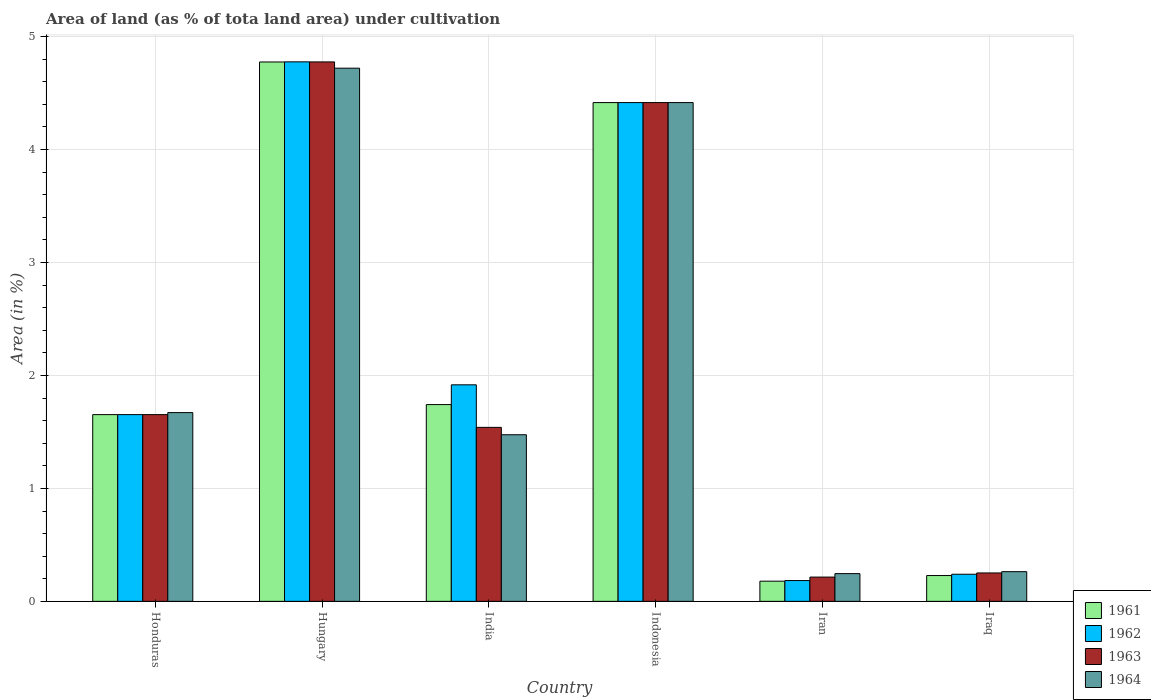How many groups of bars are there?
Provide a succinct answer. 6. Are the number of bars per tick equal to the number of legend labels?
Keep it short and to the point. Yes. How many bars are there on the 3rd tick from the left?
Your response must be concise. 4. How many bars are there on the 3rd tick from the right?
Offer a very short reply. 4. What is the label of the 2nd group of bars from the left?
Make the answer very short. Hungary. What is the percentage of land under cultivation in 1962 in Indonesia?
Your response must be concise. 4.42. Across all countries, what is the maximum percentage of land under cultivation in 1963?
Keep it short and to the point. 4.78. Across all countries, what is the minimum percentage of land under cultivation in 1962?
Provide a short and direct response. 0.18. In which country was the percentage of land under cultivation in 1962 maximum?
Your response must be concise. Hungary. In which country was the percentage of land under cultivation in 1964 minimum?
Provide a short and direct response. Iran. What is the total percentage of land under cultivation in 1963 in the graph?
Provide a succinct answer. 12.85. What is the difference between the percentage of land under cultivation in 1962 in Hungary and that in Iran?
Give a very brief answer. 4.59. What is the difference between the percentage of land under cultivation in 1964 in Honduras and the percentage of land under cultivation in 1963 in Iran?
Your answer should be very brief. 1.46. What is the average percentage of land under cultivation in 1963 per country?
Offer a terse response. 2.14. What is the difference between the percentage of land under cultivation of/in 1961 and percentage of land under cultivation of/in 1962 in Iraq?
Keep it short and to the point. -0.01. In how many countries, is the percentage of land under cultivation in 1962 greater than 4.2 %?
Your answer should be very brief. 2. What is the ratio of the percentage of land under cultivation in 1964 in India to that in Iran?
Offer a very short reply. 6.01. What is the difference between the highest and the second highest percentage of land under cultivation in 1964?
Your answer should be very brief. -3.05. What is the difference between the highest and the lowest percentage of land under cultivation in 1962?
Your answer should be very brief. 4.59. Is the sum of the percentage of land under cultivation in 1962 in Honduras and Indonesia greater than the maximum percentage of land under cultivation in 1964 across all countries?
Ensure brevity in your answer.  Yes. Is it the case that in every country, the sum of the percentage of land under cultivation in 1963 and percentage of land under cultivation in 1961 is greater than the sum of percentage of land under cultivation in 1962 and percentage of land under cultivation in 1964?
Offer a terse response. No. What does the 2nd bar from the left in Indonesia represents?
Ensure brevity in your answer.  1962. What does the 1st bar from the right in Iraq represents?
Keep it short and to the point. 1964. Are all the bars in the graph horizontal?
Your answer should be compact. No. Are the values on the major ticks of Y-axis written in scientific E-notation?
Make the answer very short. No. Does the graph contain grids?
Make the answer very short. Yes. How many legend labels are there?
Offer a terse response. 4. How are the legend labels stacked?
Your response must be concise. Vertical. What is the title of the graph?
Give a very brief answer. Area of land (as % of tota land area) under cultivation. Does "1965" appear as one of the legend labels in the graph?
Give a very brief answer. No. What is the label or title of the Y-axis?
Keep it short and to the point. Area (in %). What is the Area (in %) in 1961 in Honduras?
Provide a succinct answer. 1.65. What is the Area (in %) of 1962 in Honduras?
Offer a very short reply. 1.65. What is the Area (in %) in 1963 in Honduras?
Offer a very short reply. 1.65. What is the Area (in %) in 1964 in Honduras?
Your response must be concise. 1.67. What is the Area (in %) in 1961 in Hungary?
Your answer should be very brief. 4.78. What is the Area (in %) of 1962 in Hungary?
Make the answer very short. 4.78. What is the Area (in %) in 1963 in Hungary?
Keep it short and to the point. 4.78. What is the Area (in %) in 1964 in Hungary?
Provide a succinct answer. 4.72. What is the Area (in %) of 1961 in India?
Your answer should be very brief. 1.74. What is the Area (in %) in 1962 in India?
Make the answer very short. 1.92. What is the Area (in %) of 1963 in India?
Your answer should be very brief. 1.54. What is the Area (in %) in 1964 in India?
Your answer should be very brief. 1.48. What is the Area (in %) of 1961 in Indonesia?
Keep it short and to the point. 4.42. What is the Area (in %) of 1962 in Indonesia?
Provide a succinct answer. 4.42. What is the Area (in %) of 1963 in Indonesia?
Ensure brevity in your answer.  4.42. What is the Area (in %) of 1964 in Indonesia?
Give a very brief answer. 4.42. What is the Area (in %) of 1961 in Iran?
Provide a succinct answer. 0.18. What is the Area (in %) in 1962 in Iran?
Give a very brief answer. 0.18. What is the Area (in %) in 1963 in Iran?
Your answer should be compact. 0.21. What is the Area (in %) of 1964 in Iran?
Provide a succinct answer. 0.25. What is the Area (in %) of 1961 in Iraq?
Offer a terse response. 0.23. What is the Area (in %) in 1962 in Iraq?
Give a very brief answer. 0.24. What is the Area (in %) in 1963 in Iraq?
Keep it short and to the point. 0.25. What is the Area (in %) in 1964 in Iraq?
Give a very brief answer. 0.26. Across all countries, what is the maximum Area (in %) of 1961?
Give a very brief answer. 4.78. Across all countries, what is the maximum Area (in %) of 1962?
Make the answer very short. 4.78. Across all countries, what is the maximum Area (in %) in 1963?
Keep it short and to the point. 4.78. Across all countries, what is the maximum Area (in %) of 1964?
Give a very brief answer. 4.72. Across all countries, what is the minimum Area (in %) of 1961?
Offer a very short reply. 0.18. Across all countries, what is the minimum Area (in %) in 1962?
Give a very brief answer. 0.18. Across all countries, what is the minimum Area (in %) of 1963?
Offer a terse response. 0.21. Across all countries, what is the minimum Area (in %) of 1964?
Your response must be concise. 0.25. What is the total Area (in %) of 1961 in the graph?
Ensure brevity in your answer.  12.99. What is the total Area (in %) of 1962 in the graph?
Keep it short and to the point. 13.19. What is the total Area (in %) of 1963 in the graph?
Offer a very short reply. 12.85. What is the total Area (in %) in 1964 in the graph?
Keep it short and to the point. 12.79. What is the difference between the Area (in %) in 1961 in Honduras and that in Hungary?
Make the answer very short. -3.12. What is the difference between the Area (in %) in 1962 in Honduras and that in Hungary?
Provide a succinct answer. -3.12. What is the difference between the Area (in %) of 1963 in Honduras and that in Hungary?
Your answer should be compact. -3.12. What is the difference between the Area (in %) in 1964 in Honduras and that in Hungary?
Provide a short and direct response. -3.05. What is the difference between the Area (in %) of 1961 in Honduras and that in India?
Your answer should be compact. -0.09. What is the difference between the Area (in %) of 1962 in Honduras and that in India?
Give a very brief answer. -0.26. What is the difference between the Area (in %) of 1963 in Honduras and that in India?
Make the answer very short. 0.11. What is the difference between the Area (in %) of 1964 in Honduras and that in India?
Ensure brevity in your answer.  0.2. What is the difference between the Area (in %) of 1961 in Honduras and that in Indonesia?
Your answer should be compact. -2.76. What is the difference between the Area (in %) in 1962 in Honduras and that in Indonesia?
Give a very brief answer. -2.76. What is the difference between the Area (in %) in 1963 in Honduras and that in Indonesia?
Your answer should be very brief. -2.76. What is the difference between the Area (in %) in 1964 in Honduras and that in Indonesia?
Ensure brevity in your answer.  -2.74. What is the difference between the Area (in %) of 1961 in Honduras and that in Iran?
Offer a terse response. 1.47. What is the difference between the Area (in %) in 1962 in Honduras and that in Iran?
Provide a short and direct response. 1.47. What is the difference between the Area (in %) of 1963 in Honduras and that in Iran?
Provide a succinct answer. 1.44. What is the difference between the Area (in %) of 1964 in Honduras and that in Iran?
Offer a very short reply. 1.43. What is the difference between the Area (in %) of 1961 in Honduras and that in Iraq?
Make the answer very short. 1.42. What is the difference between the Area (in %) of 1962 in Honduras and that in Iraq?
Keep it short and to the point. 1.41. What is the difference between the Area (in %) in 1963 in Honduras and that in Iraq?
Your answer should be compact. 1.4. What is the difference between the Area (in %) in 1964 in Honduras and that in Iraq?
Make the answer very short. 1.41. What is the difference between the Area (in %) of 1961 in Hungary and that in India?
Keep it short and to the point. 3.03. What is the difference between the Area (in %) of 1962 in Hungary and that in India?
Offer a very short reply. 2.86. What is the difference between the Area (in %) of 1963 in Hungary and that in India?
Your response must be concise. 3.24. What is the difference between the Area (in %) of 1964 in Hungary and that in India?
Offer a terse response. 3.25. What is the difference between the Area (in %) of 1961 in Hungary and that in Indonesia?
Your answer should be very brief. 0.36. What is the difference between the Area (in %) of 1962 in Hungary and that in Indonesia?
Give a very brief answer. 0.36. What is the difference between the Area (in %) of 1963 in Hungary and that in Indonesia?
Offer a terse response. 0.36. What is the difference between the Area (in %) in 1964 in Hungary and that in Indonesia?
Your answer should be very brief. 0.3. What is the difference between the Area (in %) of 1961 in Hungary and that in Iran?
Make the answer very short. 4.6. What is the difference between the Area (in %) in 1962 in Hungary and that in Iran?
Make the answer very short. 4.59. What is the difference between the Area (in %) in 1963 in Hungary and that in Iran?
Ensure brevity in your answer.  4.56. What is the difference between the Area (in %) in 1964 in Hungary and that in Iran?
Your response must be concise. 4.47. What is the difference between the Area (in %) in 1961 in Hungary and that in Iraq?
Your answer should be very brief. 4.55. What is the difference between the Area (in %) in 1962 in Hungary and that in Iraq?
Your answer should be compact. 4.54. What is the difference between the Area (in %) of 1963 in Hungary and that in Iraq?
Provide a short and direct response. 4.52. What is the difference between the Area (in %) of 1964 in Hungary and that in Iraq?
Ensure brevity in your answer.  4.46. What is the difference between the Area (in %) in 1961 in India and that in Indonesia?
Your answer should be very brief. -2.67. What is the difference between the Area (in %) of 1962 in India and that in Indonesia?
Give a very brief answer. -2.5. What is the difference between the Area (in %) of 1963 in India and that in Indonesia?
Ensure brevity in your answer.  -2.88. What is the difference between the Area (in %) in 1964 in India and that in Indonesia?
Provide a succinct answer. -2.94. What is the difference between the Area (in %) in 1961 in India and that in Iran?
Keep it short and to the point. 1.56. What is the difference between the Area (in %) in 1962 in India and that in Iran?
Ensure brevity in your answer.  1.73. What is the difference between the Area (in %) of 1963 in India and that in Iran?
Give a very brief answer. 1.33. What is the difference between the Area (in %) of 1964 in India and that in Iran?
Provide a succinct answer. 1.23. What is the difference between the Area (in %) in 1961 in India and that in Iraq?
Provide a succinct answer. 1.51. What is the difference between the Area (in %) of 1962 in India and that in Iraq?
Ensure brevity in your answer.  1.68. What is the difference between the Area (in %) in 1963 in India and that in Iraq?
Your answer should be compact. 1.29. What is the difference between the Area (in %) in 1964 in India and that in Iraq?
Provide a succinct answer. 1.21. What is the difference between the Area (in %) in 1961 in Indonesia and that in Iran?
Provide a succinct answer. 4.24. What is the difference between the Area (in %) of 1962 in Indonesia and that in Iran?
Ensure brevity in your answer.  4.23. What is the difference between the Area (in %) of 1963 in Indonesia and that in Iran?
Your answer should be very brief. 4.2. What is the difference between the Area (in %) of 1964 in Indonesia and that in Iran?
Keep it short and to the point. 4.17. What is the difference between the Area (in %) of 1961 in Indonesia and that in Iraq?
Make the answer very short. 4.19. What is the difference between the Area (in %) in 1962 in Indonesia and that in Iraq?
Make the answer very short. 4.18. What is the difference between the Area (in %) of 1963 in Indonesia and that in Iraq?
Ensure brevity in your answer.  4.16. What is the difference between the Area (in %) in 1964 in Indonesia and that in Iraq?
Make the answer very short. 4.15. What is the difference between the Area (in %) of 1962 in Iran and that in Iraq?
Offer a terse response. -0.06. What is the difference between the Area (in %) of 1963 in Iran and that in Iraq?
Give a very brief answer. -0.04. What is the difference between the Area (in %) in 1964 in Iran and that in Iraq?
Provide a short and direct response. -0.02. What is the difference between the Area (in %) in 1961 in Honduras and the Area (in %) in 1962 in Hungary?
Your response must be concise. -3.12. What is the difference between the Area (in %) of 1961 in Honduras and the Area (in %) of 1963 in Hungary?
Offer a very short reply. -3.12. What is the difference between the Area (in %) in 1961 in Honduras and the Area (in %) in 1964 in Hungary?
Your answer should be compact. -3.07. What is the difference between the Area (in %) in 1962 in Honduras and the Area (in %) in 1963 in Hungary?
Offer a terse response. -3.12. What is the difference between the Area (in %) of 1962 in Honduras and the Area (in %) of 1964 in Hungary?
Offer a terse response. -3.07. What is the difference between the Area (in %) in 1963 in Honduras and the Area (in %) in 1964 in Hungary?
Provide a succinct answer. -3.07. What is the difference between the Area (in %) in 1961 in Honduras and the Area (in %) in 1962 in India?
Your answer should be compact. -0.26. What is the difference between the Area (in %) in 1961 in Honduras and the Area (in %) in 1963 in India?
Keep it short and to the point. 0.11. What is the difference between the Area (in %) of 1961 in Honduras and the Area (in %) of 1964 in India?
Make the answer very short. 0.18. What is the difference between the Area (in %) in 1962 in Honduras and the Area (in %) in 1963 in India?
Provide a short and direct response. 0.11. What is the difference between the Area (in %) in 1962 in Honduras and the Area (in %) in 1964 in India?
Give a very brief answer. 0.18. What is the difference between the Area (in %) of 1963 in Honduras and the Area (in %) of 1964 in India?
Offer a terse response. 0.18. What is the difference between the Area (in %) in 1961 in Honduras and the Area (in %) in 1962 in Indonesia?
Ensure brevity in your answer.  -2.76. What is the difference between the Area (in %) in 1961 in Honduras and the Area (in %) in 1963 in Indonesia?
Offer a terse response. -2.76. What is the difference between the Area (in %) in 1961 in Honduras and the Area (in %) in 1964 in Indonesia?
Make the answer very short. -2.76. What is the difference between the Area (in %) in 1962 in Honduras and the Area (in %) in 1963 in Indonesia?
Provide a succinct answer. -2.76. What is the difference between the Area (in %) of 1962 in Honduras and the Area (in %) of 1964 in Indonesia?
Keep it short and to the point. -2.76. What is the difference between the Area (in %) in 1963 in Honduras and the Area (in %) in 1964 in Indonesia?
Give a very brief answer. -2.76. What is the difference between the Area (in %) in 1961 in Honduras and the Area (in %) in 1962 in Iran?
Offer a terse response. 1.47. What is the difference between the Area (in %) of 1961 in Honduras and the Area (in %) of 1963 in Iran?
Provide a succinct answer. 1.44. What is the difference between the Area (in %) of 1961 in Honduras and the Area (in %) of 1964 in Iran?
Your response must be concise. 1.41. What is the difference between the Area (in %) in 1962 in Honduras and the Area (in %) in 1963 in Iran?
Make the answer very short. 1.44. What is the difference between the Area (in %) of 1962 in Honduras and the Area (in %) of 1964 in Iran?
Provide a short and direct response. 1.41. What is the difference between the Area (in %) of 1963 in Honduras and the Area (in %) of 1964 in Iran?
Your answer should be compact. 1.41. What is the difference between the Area (in %) in 1961 in Honduras and the Area (in %) in 1962 in Iraq?
Provide a short and direct response. 1.41. What is the difference between the Area (in %) in 1961 in Honduras and the Area (in %) in 1963 in Iraq?
Your answer should be very brief. 1.4. What is the difference between the Area (in %) of 1961 in Honduras and the Area (in %) of 1964 in Iraq?
Your response must be concise. 1.39. What is the difference between the Area (in %) in 1962 in Honduras and the Area (in %) in 1963 in Iraq?
Provide a short and direct response. 1.4. What is the difference between the Area (in %) of 1962 in Honduras and the Area (in %) of 1964 in Iraq?
Your answer should be compact. 1.39. What is the difference between the Area (in %) of 1963 in Honduras and the Area (in %) of 1964 in Iraq?
Provide a succinct answer. 1.39. What is the difference between the Area (in %) in 1961 in Hungary and the Area (in %) in 1962 in India?
Your answer should be very brief. 2.86. What is the difference between the Area (in %) of 1961 in Hungary and the Area (in %) of 1963 in India?
Your answer should be very brief. 3.24. What is the difference between the Area (in %) of 1961 in Hungary and the Area (in %) of 1964 in India?
Give a very brief answer. 3.3. What is the difference between the Area (in %) of 1962 in Hungary and the Area (in %) of 1963 in India?
Your answer should be compact. 3.24. What is the difference between the Area (in %) in 1962 in Hungary and the Area (in %) in 1964 in India?
Provide a succinct answer. 3.3. What is the difference between the Area (in %) in 1963 in Hungary and the Area (in %) in 1964 in India?
Your answer should be compact. 3.3. What is the difference between the Area (in %) of 1961 in Hungary and the Area (in %) of 1962 in Indonesia?
Your response must be concise. 0.36. What is the difference between the Area (in %) of 1961 in Hungary and the Area (in %) of 1963 in Indonesia?
Give a very brief answer. 0.36. What is the difference between the Area (in %) of 1961 in Hungary and the Area (in %) of 1964 in Indonesia?
Offer a very short reply. 0.36. What is the difference between the Area (in %) of 1962 in Hungary and the Area (in %) of 1963 in Indonesia?
Provide a succinct answer. 0.36. What is the difference between the Area (in %) in 1962 in Hungary and the Area (in %) in 1964 in Indonesia?
Your answer should be very brief. 0.36. What is the difference between the Area (in %) of 1963 in Hungary and the Area (in %) of 1964 in Indonesia?
Make the answer very short. 0.36. What is the difference between the Area (in %) of 1961 in Hungary and the Area (in %) of 1962 in Iran?
Keep it short and to the point. 4.59. What is the difference between the Area (in %) of 1961 in Hungary and the Area (in %) of 1963 in Iran?
Make the answer very short. 4.56. What is the difference between the Area (in %) of 1961 in Hungary and the Area (in %) of 1964 in Iran?
Offer a terse response. 4.53. What is the difference between the Area (in %) in 1962 in Hungary and the Area (in %) in 1963 in Iran?
Offer a very short reply. 4.56. What is the difference between the Area (in %) of 1962 in Hungary and the Area (in %) of 1964 in Iran?
Make the answer very short. 4.53. What is the difference between the Area (in %) of 1963 in Hungary and the Area (in %) of 1964 in Iran?
Provide a succinct answer. 4.53. What is the difference between the Area (in %) of 1961 in Hungary and the Area (in %) of 1962 in Iraq?
Your answer should be compact. 4.54. What is the difference between the Area (in %) of 1961 in Hungary and the Area (in %) of 1963 in Iraq?
Offer a terse response. 4.52. What is the difference between the Area (in %) in 1961 in Hungary and the Area (in %) in 1964 in Iraq?
Offer a very short reply. 4.51. What is the difference between the Area (in %) in 1962 in Hungary and the Area (in %) in 1963 in Iraq?
Provide a short and direct response. 4.53. What is the difference between the Area (in %) of 1962 in Hungary and the Area (in %) of 1964 in Iraq?
Provide a short and direct response. 4.51. What is the difference between the Area (in %) of 1963 in Hungary and the Area (in %) of 1964 in Iraq?
Provide a succinct answer. 4.51. What is the difference between the Area (in %) in 1961 in India and the Area (in %) in 1962 in Indonesia?
Offer a terse response. -2.67. What is the difference between the Area (in %) in 1961 in India and the Area (in %) in 1963 in Indonesia?
Your answer should be very brief. -2.67. What is the difference between the Area (in %) in 1961 in India and the Area (in %) in 1964 in Indonesia?
Your response must be concise. -2.67. What is the difference between the Area (in %) of 1962 in India and the Area (in %) of 1963 in Indonesia?
Your response must be concise. -2.5. What is the difference between the Area (in %) in 1962 in India and the Area (in %) in 1964 in Indonesia?
Offer a terse response. -2.5. What is the difference between the Area (in %) in 1963 in India and the Area (in %) in 1964 in Indonesia?
Your answer should be compact. -2.88. What is the difference between the Area (in %) of 1961 in India and the Area (in %) of 1962 in Iran?
Give a very brief answer. 1.56. What is the difference between the Area (in %) in 1961 in India and the Area (in %) in 1963 in Iran?
Provide a succinct answer. 1.53. What is the difference between the Area (in %) of 1961 in India and the Area (in %) of 1964 in Iran?
Offer a terse response. 1.5. What is the difference between the Area (in %) in 1962 in India and the Area (in %) in 1963 in Iran?
Ensure brevity in your answer.  1.7. What is the difference between the Area (in %) in 1962 in India and the Area (in %) in 1964 in Iran?
Your answer should be compact. 1.67. What is the difference between the Area (in %) in 1963 in India and the Area (in %) in 1964 in Iran?
Offer a terse response. 1.29. What is the difference between the Area (in %) in 1961 in India and the Area (in %) in 1962 in Iraq?
Your response must be concise. 1.5. What is the difference between the Area (in %) of 1961 in India and the Area (in %) of 1963 in Iraq?
Your answer should be compact. 1.49. What is the difference between the Area (in %) of 1961 in India and the Area (in %) of 1964 in Iraq?
Offer a very short reply. 1.48. What is the difference between the Area (in %) in 1962 in India and the Area (in %) in 1963 in Iraq?
Provide a short and direct response. 1.67. What is the difference between the Area (in %) in 1962 in India and the Area (in %) in 1964 in Iraq?
Your answer should be compact. 1.65. What is the difference between the Area (in %) of 1963 in India and the Area (in %) of 1964 in Iraq?
Provide a succinct answer. 1.28. What is the difference between the Area (in %) in 1961 in Indonesia and the Area (in %) in 1962 in Iran?
Provide a short and direct response. 4.23. What is the difference between the Area (in %) of 1961 in Indonesia and the Area (in %) of 1963 in Iran?
Provide a short and direct response. 4.2. What is the difference between the Area (in %) in 1961 in Indonesia and the Area (in %) in 1964 in Iran?
Ensure brevity in your answer.  4.17. What is the difference between the Area (in %) of 1962 in Indonesia and the Area (in %) of 1963 in Iran?
Provide a succinct answer. 4.2. What is the difference between the Area (in %) of 1962 in Indonesia and the Area (in %) of 1964 in Iran?
Ensure brevity in your answer.  4.17. What is the difference between the Area (in %) in 1963 in Indonesia and the Area (in %) in 1964 in Iran?
Your answer should be very brief. 4.17. What is the difference between the Area (in %) of 1961 in Indonesia and the Area (in %) of 1962 in Iraq?
Offer a terse response. 4.18. What is the difference between the Area (in %) of 1961 in Indonesia and the Area (in %) of 1963 in Iraq?
Your answer should be very brief. 4.16. What is the difference between the Area (in %) in 1961 in Indonesia and the Area (in %) in 1964 in Iraq?
Your answer should be compact. 4.15. What is the difference between the Area (in %) in 1962 in Indonesia and the Area (in %) in 1963 in Iraq?
Your response must be concise. 4.16. What is the difference between the Area (in %) of 1962 in Indonesia and the Area (in %) of 1964 in Iraq?
Provide a short and direct response. 4.15. What is the difference between the Area (in %) in 1963 in Indonesia and the Area (in %) in 1964 in Iraq?
Offer a very short reply. 4.15. What is the difference between the Area (in %) in 1961 in Iran and the Area (in %) in 1962 in Iraq?
Your answer should be compact. -0.06. What is the difference between the Area (in %) in 1961 in Iran and the Area (in %) in 1963 in Iraq?
Offer a terse response. -0.07. What is the difference between the Area (in %) of 1961 in Iran and the Area (in %) of 1964 in Iraq?
Provide a short and direct response. -0.08. What is the difference between the Area (in %) in 1962 in Iran and the Area (in %) in 1963 in Iraq?
Your response must be concise. -0.07. What is the difference between the Area (in %) of 1962 in Iran and the Area (in %) of 1964 in Iraq?
Give a very brief answer. -0.08. What is the difference between the Area (in %) of 1963 in Iran and the Area (in %) of 1964 in Iraq?
Your answer should be compact. -0.05. What is the average Area (in %) of 1961 per country?
Provide a short and direct response. 2.17. What is the average Area (in %) in 1962 per country?
Give a very brief answer. 2.2. What is the average Area (in %) in 1963 per country?
Offer a terse response. 2.14. What is the average Area (in %) in 1964 per country?
Give a very brief answer. 2.13. What is the difference between the Area (in %) of 1961 and Area (in %) of 1964 in Honduras?
Your response must be concise. -0.02. What is the difference between the Area (in %) of 1962 and Area (in %) of 1963 in Honduras?
Your response must be concise. 0. What is the difference between the Area (in %) in 1962 and Area (in %) in 1964 in Honduras?
Make the answer very short. -0.02. What is the difference between the Area (in %) in 1963 and Area (in %) in 1964 in Honduras?
Provide a succinct answer. -0.02. What is the difference between the Area (in %) of 1961 and Area (in %) of 1962 in Hungary?
Offer a terse response. -0. What is the difference between the Area (in %) in 1961 and Area (in %) in 1963 in Hungary?
Give a very brief answer. -0. What is the difference between the Area (in %) of 1961 and Area (in %) of 1964 in Hungary?
Ensure brevity in your answer.  0.06. What is the difference between the Area (in %) in 1962 and Area (in %) in 1963 in Hungary?
Ensure brevity in your answer.  0. What is the difference between the Area (in %) of 1962 and Area (in %) of 1964 in Hungary?
Provide a succinct answer. 0.06. What is the difference between the Area (in %) in 1963 and Area (in %) in 1964 in Hungary?
Provide a short and direct response. 0.06. What is the difference between the Area (in %) of 1961 and Area (in %) of 1962 in India?
Your response must be concise. -0.17. What is the difference between the Area (in %) in 1961 and Area (in %) in 1963 in India?
Offer a terse response. 0.2. What is the difference between the Area (in %) of 1961 and Area (in %) of 1964 in India?
Offer a very short reply. 0.27. What is the difference between the Area (in %) in 1962 and Area (in %) in 1963 in India?
Provide a succinct answer. 0.38. What is the difference between the Area (in %) of 1962 and Area (in %) of 1964 in India?
Make the answer very short. 0.44. What is the difference between the Area (in %) of 1963 and Area (in %) of 1964 in India?
Provide a short and direct response. 0.07. What is the difference between the Area (in %) of 1961 and Area (in %) of 1962 in Indonesia?
Provide a succinct answer. 0. What is the difference between the Area (in %) in 1961 and Area (in %) in 1964 in Indonesia?
Your response must be concise. 0. What is the difference between the Area (in %) in 1963 and Area (in %) in 1964 in Indonesia?
Provide a succinct answer. 0. What is the difference between the Area (in %) of 1961 and Area (in %) of 1962 in Iran?
Give a very brief answer. -0.01. What is the difference between the Area (in %) of 1961 and Area (in %) of 1963 in Iran?
Your response must be concise. -0.04. What is the difference between the Area (in %) in 1961 and Area (in %) in 1964 in Iran?
Keep it short and to the point. -0.07. What is the difference between the Area (in %) in 1962 and Area (in %) in 1963 in Iran?
Your answer should be very brief. -0.03. What is the difference between the Area (in %) of 1962 and Area (in %) of 1964 in Iran?
Your response must be concise. -0.06. What is the difference between the Area (in %) of 1963 and Area (in %) of 1964 in Iran?
Keep it short and to the point. -0.03. What is the difference between the Area (in %) of 1961 and Area (in %) of 1962 in Iraq?
Provide a succinct answer. -0.01. What is the difference between the Area (in %) of 1961 and Area (in %) of 1963 in Iraq?
Give a very brief answer. -0.02. What is the difference between the Area (in %) in 1961 and Area (in %) in 1964 in Iraq?
Offer a very short reply. -0.03. What is the difference between the Area (in %) in 1962 and Area (in %) in 1963 in Iraq?
Keep it short and to the point. -0.01. What is the difference between the Area (in %) of 1962 and Area (in %) of 1964 in Iraq?
Provide a succinct answer. -0.02. What is the difference between the Area (in %) in 1963 and Area (in %) in 1964 in Iraq?
Your answer should be compact. -0.01. What is the ratio of the Area (in %) in 1961 in Honduras to that in Hungary?
Your answer should be very brief. 0.35. What is the ratio of the Area (in %) of 1962 in Honduras to that in Hungary?
Offer a terse response. 0.35. What is the ratio of the Area (in %) in 1963 in Honduras to that in Hungary?
Your response must be concise. 0.35. What is the ratio of the Area (in %) of 1964 in Honduras to that in Hungary?
Provide a succinct answer. 0.35. What is the ratio of the Area (in %) in 1961 in Honduras to that in India?
Keep it short and to the point. 0.95. What is the ratio of the Area (in %) of 1962 in Honduras to that in India?
Provide a short and direct response. 0.86. What is the ratio of the Area (in %) in 1963 in Honduras to that in India?
Ensure brevity in your answer.  1.07. What is the ratio of the Area (in %) of 1964 in Honduras to that in India?
Your answer should be compact. 1.13. What is the ratio of the Area (in %) of 1961 in Honduras to that in Indonesia?
Keep it short and to the point. 0.37. What is the ratio of the Area (in %) in 1962 in Honduras to that in Indonesia?
Keep it short and to the point. 0.37. What is the ratio of the Area (in %) in 1963 in Honduras to that in Indonesia?
Make the answer very short. 0.37. What is the ratio of the Area (in %) of 1964 in Honduras to that in Indonesia?
Keep it short and to the point. 0.38. What is the ratio of the Area (in %) in 1961 in Honduras to that in Iran?
Offer a very short reply. 9.25. What is the ratio of the Area (in %) of 1962 in Honduras to that in Iran?
Your response must be concise. 8.98. What is the ratio of the Area (in %) in 1963 in Honduras to that in Iran?
Give a very brief answer. 7.69. What is the ratio of the Area (in %) in 1964 in Honduras to that in Iran?
Offer a very short reply. 6.8. What is the ratio of the Area (in %) in 1961 in Honduras to that in Iraq?
Offer a terse response. 7.23. What is the ratio of the Area (in %) of 1962 in Honduras to that in Iraq?
Keep it short and to the point. 6.89. What is the ratio of the Area (in %) in 1963 in Honduras to that in Iraq?
Offer a terse response. 6.57. What is the ratio of the Area (in %) of 1964 in Honduras to that in Iraq?
Make the answer very short. 6.36. What is the ratio of the Area (in %) in 1961 in Hungary to that in India?
Your answer should be very brief. 2.74. What is the ratio of the Area (in %) in 1962 in Hungary to that in India?
Offer a terse response. 2.49. What is the ratio of the Area (in %) in 1963 in Hungary to that in India?
Offer a very short reply. 3.1. What is the ratio of the Area (in %) in 1964 in Hungary to that in India?
Keep it short and to the point. 3.2. What is the ratio of the Area (in %) in 1961 in Hungary to that in Indonesia?
Offer a very short reply. 1.08. What is the ratio of the Area (in %) of 1962 in Hungary to that in Indonesia?
Offer a terse response. 1.08. What is the ratio of the Area (in %) in 1963 in Hungary to that in Indonesia?
Your response must be concise. 1.08. What is the ratio of the Area (in %) in 1964 in Hungary to that in Indonesia?
Your answer should be very brief. 1.07. What is the ratio of the Area (in %) in 1961 in Hungary to that in Iran?
Your answer should be compact. 26.73. What is the ratio of the Area (in %) in 1962 in Hungary to that in Iran?
Keep it short and to the point. 25.93. What is the ratio of the Area (in %) in 1963 in Hungary to that in Iran?
Make the answer very short. 22.22. What is the ratio of the Area (in %) in 1964 in Hungary to that in Iran?
Provide a short and direct response. 19.22. What is the ratio of the Area (in %) in 1961 in Hungary to that in Iraq?
Provide a short and direct response. 20.89. What is the ratio of the Area (in %) of 1962 in Hungary to that in Iraq?
Give a very brief answer. 19.9. What is the ratio of the Area (in %) of 1963 in Hungary to that in Iraq?
Your answer should be very brief. 18.99. What is the ratio of the Area (in %) in 1964 in Hungary to that in Iraq?
Your answer should be very brief. 17.95. What is the ratio of the Area (in %) in 1961 in India to that in Indonesia?
Provide a succinct answer. 0.39. What is the ratio of the Area (in %) of 1962 in India to that in Indonesia?
Provide a succinct answer. 0.43. What is the ratio of the Area (in %) of 1963 in India to that in Indonesia?
Provide a short and direct response. 0.35. What is the ratio of the Area (in %) of 1964 in India to that in Indonesia?
Your answer should be compact. 0.33. What is the ratio of the Area (in %) of 1961 in India to that in Iran?
Provide a short and direct response. 9.75. What is the ratio of the Area (in %) in 1962 in India to that in Iran?
Keep it short and to the point. 10.41. What is the ratio of the Area (in %) of 1963 in India to that in Iran?
Your response must be concise. 7.17. What is the ratio of the Area (in %) in 1964 in India to that in Iran?
Your answer should be compact. 6.01. What is the ratio of the Area (in %) of 1961 in India to that in Iraq?
Provide a short and direct response. 7.62. What is the ratio of the Area (in %) of 1962 in India to that in Iraq?
Provide a succinct answer. 7.99. What is the ratio of the Area (in %) in 1963 in India to that in Iraq?
Ensure brevity in your answer.  6.12. What is the ratio of the Area (in %) of 1964 in India to that in Iraq?
Make the answer very short. 5.61. What is the ratio of the Area (in %) in 1961 in Indonesia to that in Iran?
Your response must be concise. 24.71. What is the ratio of the Area (in %) of 1962 in Indonesia to that in Iran?
Your answer should be very brief. 23.97. What is the ratio of the Area (in %) of 1963 in Indonesia to that in Iran?
Make the answer very short. 20.55. What is the ratio of the Area (in %) of 1964 in Indonesia to that in Iran?
Provide a succinct answer. 17.98. What is the ratio of the Area (in %) in 1961 in Indonesia to that in Iraq?
Give a very brief answer. 19.31. What is the ratio of the Area (in %) of 1962 in Indonesia to that in Iraq?
Offer a terse response. 18.39. What is the ratio of the Area (in %) of 1963 in Indonesia to that in Iraq?
Make the answer very short. 17.56. What is the ratio of the Area (in %) in 1964 in Indonesia to that in Iraq?
Make the answer very short. 16.8. What is the ratio of the Area (in %) in 1961 in Iran to that in Iraq?
Ensure brevity in your answer.  0.78. What is the ratio of the Area (in %) in 1962 in Iran to that in Iraq?
Keep it short and to the point. 0.77. What is the ratio of the Area (in %) of 1963 in Iran to that in Iraq?
Provide a succinct answer. 0.85. What is the ratio of the Area (in %) in 1964 in Iran to that in Iraq?
Provide a succinct answer. 0.93. What is the difference between the highest and the second highest Area (in %) in 1961?
Give a very brief answer. 0.36. What is the difference between the highest and the second highest Area (in %) in 1962?
Provide a short and direct response. 0.36. What is the difference between the highest and the second highest Area (in %) of 1963?
Your response must be concise. 0.36. What is the difference between the highest and the second highest Area (in %) of 1964?
Offer a very short reply. 0.3. What is the difference between the highest and the lowest Area (in %) in 1961?
Your answer should be compact. 4.6. What is the difference between the highest and the lowest Area (in %) of 1962?
Your answer should be compact. 4.59. What is the difference between the highest and the lowest Area (in %) in 1963?
Offer a very short reply. 4.56. What is the difference between the highest and the lowest Area (in %) of 1964?
Give a very brief answer. 4.47. 